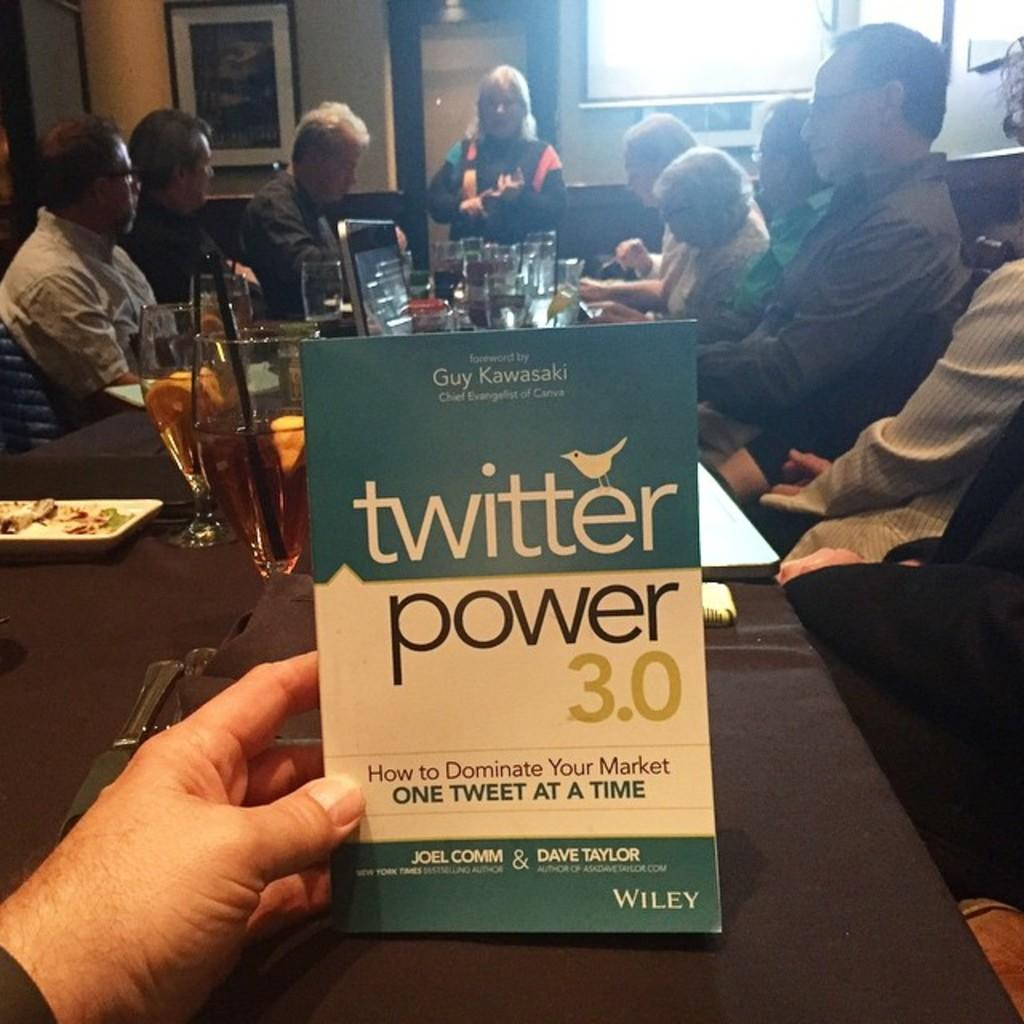<image>
Render a clear and concise summary of the photo. An ad has the twitter logo on it and is being held in someone's hand. 